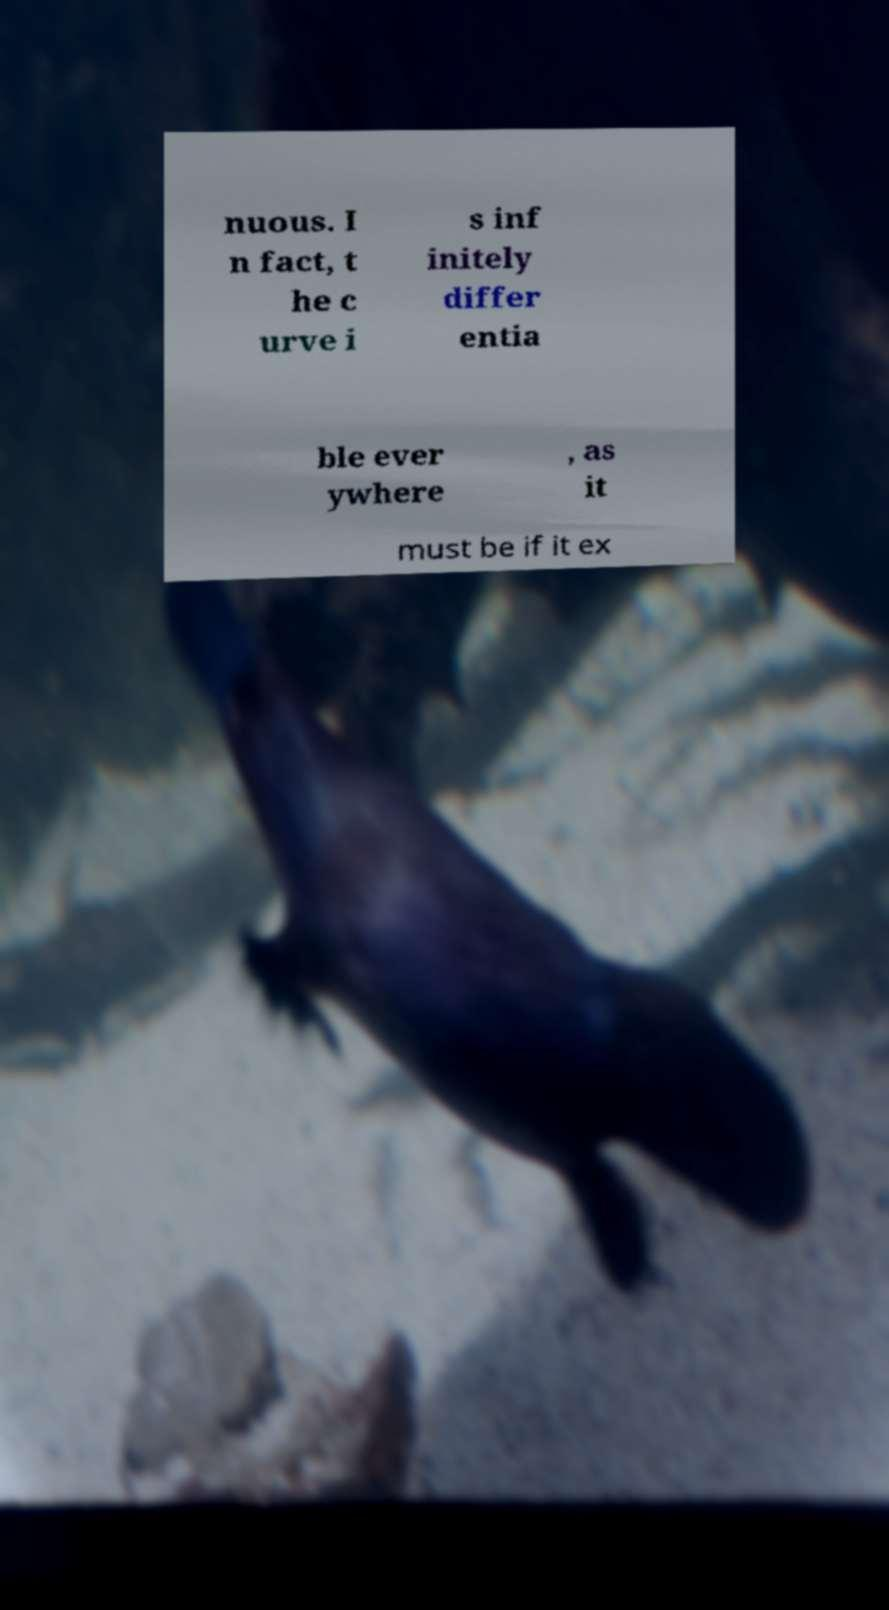Please read and relay the text visible in this image. What does it say? nuous. I n fact, t he c urve i s inf initely differ entia ble ever ywhere , as it must be if it ex 